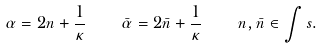Convert formula to latex. <formula><loc_0><loc_0><loc_500><loc_500>\alpha = 2 n + \frac { 1 } { \kappa } \quad \bar { \alpha } = 2 \bar { n } + \frac { 1 } { \kappa } \quad n , \bar { n } \in \int s .</formula> 